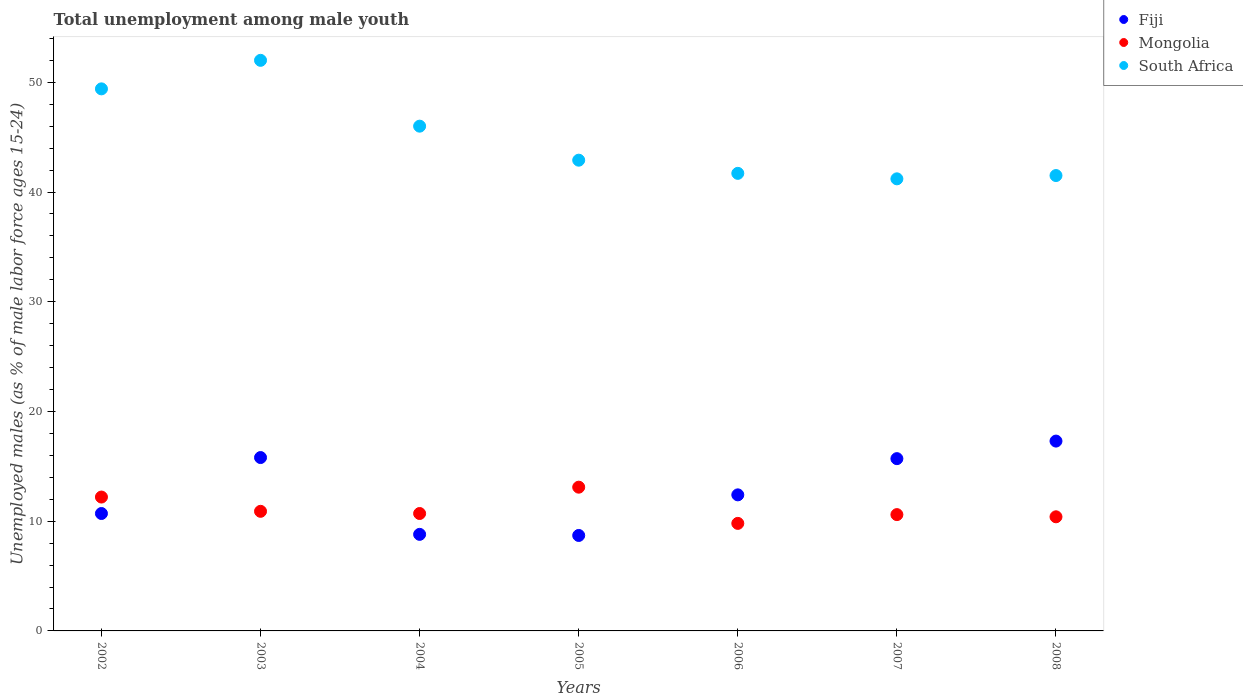What is the percentage of unemployed males in in Mongolia in 2004?
Give a very brief answer. 10.7. Across all years, what is the maximum percentage of unemployed males in in Mongolia?
Give a very brief answer. 13.1. Across all years, what is the minimum percentage of unemployed males in in South Africa?
Offer a terse response. 41.2. In which year was the percentage of unemployed males in in Mongolia minimum?
Your answer should be very brief. 2006. What is the total percentage of unemployed males in in South Africa in the graph?
Provide a short and direct response. 314.7. What is the difference between the percentage of unemployed males in in South Africa in 2002 and that in 2008?
Make the answer very short. 7.9. What is the difference between the percentage of unemployed males in in Fiji in 2002 and the percentage of unemployed males in in South Africa in 2003?
Offer a terse response. -41.3. What is the average percentage of unemployed males in in South Africa per year?
Your answer should be compact. 44.96. In the year 2005, what is the difference between the percentage of unemployed males in in Fiji and percentage of unemployed males in in Mongolia?
Your answer should be very brief. -4.4. What is the ratio of the percentage of unemployed males in in Mongolia in 2002 to that in 2004?
Make the answer very short. 1.14. Is the percentage of unemployed males in in South Africa in 2005 less than that in 2006?
Make the answer very short. No. What is the difference between the highest and the second highest percentage of unemployed males in in Mongolia?
Offer a terse response. 0.9. What is the difference between the highest and the lowest percentage of unemployed males in in Mongolia?
Make the answer very short. 3.3. Is the sum of the percentage of unemployed males in in Fiji in 2006 and 2008 greater than the maximum percentage of unemployed males in in Mongolia across all years?
Make the answer very short. Yes. Is it the case that in every year, the sum of the percentage of unemployed males in in Mongolia and percentage of unemployed males in in Fiji  is greater than the percentage of unemployed males in in South Africa?
Keep it short and to the point. No. Does the percentage of unemployed males in in South Africa monotonically increase over the years?
Offer a terse response. No. Is the percentage of unemployed males in in Fiji strictly greater than the percentage of unemployed males in in South Africa over the years?
Offer a very short reply. No. Is the percentage of unemployed males in in South Africa strictly less than the percentage of unemployed males in in Fiji over the years?
Your answer should be very brief. No. How many dotlines are there?
Offer a terse response. 3. How many years are there in the graph?
Give a very brief answer. 7. What is the difference between two consecutive major ticks on the Y-axis?
Make the answer very short. 10. Are the values on the major ticks of Y-axis written in scientific E-notation?
Provide a short and direct response. No. Where does the legend appear in the graph?
Ensure brevity in your answer.  Top right. How are the legend labels stacked?
Offer a terse response. Vertical. What is the title of the graph?
Your answer should be compact. Total unemployment among male youth. Does "Sudan" appear as one of the legend labels in the graph?
Give a very brief answer. No. What is the label or title of the Y-axis?
Provide a short and direct response. Unemployed males (as % of male labor force ages 15-24). What is the Unemployed males (as % of male labor force ages 15-24) of Fiji in 2002?
Your answer should be very brief. 10.7. What is the Unemployed males (as % of male labor force ages 15-24) of Mongolia in 2002?
Provide a succinct answer. 12.2. What is the Unemployed males (as % of male labor force ages 15-24) in South Africa in 2002?
Your response must be concise. 49.4. What is the Unemployed males (as % of male labor force ages 15-24) of Fiji in 2003?
Keep it short and to the point. 15.8. What is the Unemployed males (as % of male labor force ages 15-24) of Mongolia in 2003?
Your answer should be very brief. 10.9. What is the Unemployed males (as % of male labor force ages 15-24) of Fiji in 2004?
Give a very brief answer. 8.8. What is the Unemployed males (as % of male labor force ages 15-24) of Mongolia in 2004?
Your answer should be very brief. 10.7. What is the Unemployed males (as % of male labor force ages 15-24) in South Africa in 2004?
Provide a short and direct response. 46. What is the Unemployed males (as % of male labor force ages 15-24) of Fiji in 2005?
Make the answer very short. 8.7. What is the Unemployed males (as % of male labor force ages 15-24) in Mongolia in 2005?
Your response must be concise. 13.1. What is the Unemployed males (as % of male labor force ages 15-24) of South Africa in 2005?
Offer a very short reply. 42.9. What is the Unemployed males (as % of male labor force ages 15-24) in Fiji in 2006?
Your response must be concise. 12.4. What is the Unemployed males (as % of male labor force ages 15-24) in Mongolia in 2006?
Your answer should be very brief. 9.8. What is the Unemployed males (as % of male labor force ages 15-24) in South Africa in 2006?
Provide a short and direct response. 41.7. What is the Unemployed males (as % of male labor force ages 15-24) in Fiji in 2007?
Give a very brief answer. 15.7. What is the Unemployed males (as % of male labor force ages 15-24) of Mongolia in 2007?
Keep it short and to the point. 10.6. What is the Unemployed males (as % of male labor force ages 15-24) of South Africa in 2007?
Provide a succinct answer. 41.2. What is the Unemployed males (as % of male labor force ages 15-24) in Fiji in 2008?
Your answer should be compact. 17.3. What is the Unemployed males (as % of male labor force ages 15-24) of Mongolia in 2008?
Your response must be concise. 10.4. What is the Unemployed males (as % of male labor force ages 15-24) of South Africa in 2008?
Your response must be concise. 41.5. Across all years, what is the maximum Unemployed males (as % of male labor force ages 15-24) in Fiji?
Make the answer very short. 17.3. Across all years, what is the maximum Unemployed males (as % of male labor force ages 15-24) of Mongolia?
Your answer should be very brief. 13.1. Across all years, what is the minimum Unemployed males (as % of male labor force ages 15-24) of Fiji?
Offer a terse response. 8.7. Across all years, what is the minimum Unemployed males (as % of male labor force ages 15-24) in Mongolia?
Ensure brevity in your answer.  9.8. Across all years, what is the minimum Unemployed males (as % of male labor force ages 15-24) of South Africa?
Your answer should be compact. 41.2. What is the total Unemployed males (as % of male labor force ages 15-24) of Fiji in the graph?
Make the answer very short. 89.4. What is the total Unemployed males (as % of male labor force ages 15-24) of Mongolia in the graph?
Your response must be concise. 77.7. What is the total Unemployed males (as % of male labor force ages 15-24) in South Africa in the graph?
Your answer should be compact. 314.7. What is the difference between the Unemployed males (as % of male labor force ages 15-24) of Fiji in 2002 and that in 2003?
Your answer should be compact. -5.1. What is the difference between the Unemployed males (as % of male labor force ages 15-24) in Mongolia in 2002 and that in 2004?
Provide a short and direct response. 1.5. What is the difference between the Unemployed males (as % of male labor force ages 15-24) of South Africa in 2002 and that in 2004?
Provide a succinct answer. 3.4. What is the difference between the Unemployed males (as % of male labor force ages 15-24) of South Africa in 2002 and that in 2005?
Ensure brevity in your answer.  6.5. What is the difference between the Unemployed males (as % of male labor force ages 15-24) in Fiji in 2002 and that in 2006?
Your answer should be compact. -1.7. What is the difference between the Unemployed males (as % of male labor force ages 15-24) in Fiji in 2002 and that in 2007?
Provide a succinct answer. -5. What is the difference between the Unemployed males (as % of male labor force ages 15-24) in South Africa in 2002 and that in 2007?
Ensure brevity in your answer.  8.2. What is the difference between the Unemployed males (as % of male labor force ages 15-24) of Mongolia in 2002 and that in 2008?
Ensure brevity in your answer.  1.8. What is the difference between the Unemployed males (as % of male labor force ages 15-24) in South Africa in 2002 and that in 2008?
Offer a terse response. 7.9. What is the difference between the Unemployed males (as % of male labor force ages 15-24) in Fiji in 2003 and that in 2004?
Ensure brevity in your answer.  7. What is the difference between the Unemployed males (as % of male labor force ages 15-24) of Mongolia in 2003 and that in 2004?
Ensure brevity in your answer.  0.2. What is the difference between the Unemployed males (as % of male labor force ages 15-24) of South Africa in 2003 and that in 2004?
Make the answer very short. 6. What is the difference between the Unemployed males (as % of male labor force ages 15-24) of South Africa in 2003 and that in 2005?
Ensure brevity in your answer.  9.1. What is the difference between the Unemployed males (as % of male labor force ages 15-24) in Mongolia in 2003 and that in 2006?
Your answer should be compact. 1.1. What is the difference between the Unemployed males (as % of male labor force ages 15-24) in South Africa in 2003 and that in 2006?
Your response must be concise. 10.3. What is the difference between the Unemployed males (as % of male labor force ages 15-24) of Fiji in 2003 and that in 2007?
Your answer should be very brief. 0.1. What is the difference between the Unemployed males (as % of male labor force ages 15-24) in South Africa in 2003 and that in 2007?
Your answer should be compact. 10.8. What is the difference between the Unemployed males (as % of male labor force ages 15-24) of Fiji in 2003 and that in 2008?
Ensure brevity in your answer.  -1.5. What is the difference between the Unemployed males (as % of male labor force ages 15-24) in Mongolia in 2004 and that in 2005?
Provide a succinct answer. -2.4. What is the difference between the Unemployed males (as % of male labor force ages 15-24) in Mongolia in 2004 and that in 2006?
Your answer should be very brief. 0.9. What is the difference between the Unemployed males (as % of male labor force ages 15-24) of South Africa in 2004 and that in 2006?
Provide a succinct answer. 4.3. What is the difference between the Unemployed males (as % of male labor force ages 15-24) in South Africa in 2004 and that in 2008?
Offer a very short reply. 4.5. What is the difference between the Unemployed males (as % of male labor force ages 15-24) in Fiji in 2005 and that in 2006?
Offer a very short reply. -3.7. What is the difference between the Unemployed males (as % of male labor force ages 15-24) in Mongolia in 2005 and that in 2006?
Your response must be concise. 3.3. What is the difference between the Unemployed males (as % of male labor force ages 15-24) of South Africa in 2005 and that in 2006?
Provide a succinct answer. 1.2. What is the difference between the Unemployed males (as % of male labor force ages 15-24) of Mongolia in 2005 and that in 2008?
Make the answer very short. 2.7. What is the difference between the Unemployed males (as % of male labor force ages 15-24) in Fiji in 2006 and that in 2007?
Provide a short and direct response. -3.3. What is the difference between the Unemployed males (as % of male labor force ages 15-24) of Mongolia in 2006 and that in 2007?
Offer a very short reply. -0.8. What is the difference between the Unemployed males (as % of male labor force ages 15-24) of Mongolia in 2006 and that in 2008?
Give a very brief answer. -0.6. What is the difference between the Unemployed males (as % of male labor force ages 15-24) in Mongolia in 2007 and that in 2008?
Your answer should be very brief. 0.2. What is the difference between the Unemployed males (as % of male labor force ages 15-24) of Fiji in 2002 and the Unemployed males (as % of male labor force ages 15-24) of South Africa in 2003?
Your response must be concise. -41.3. What is the difference between the Unemployed males (as % of male labor force ages 15-24) of Mongolia in 2002 and the Unemployed males (as % of male labor force ages 15-24) of South Africa in 2003?
Keep it short and to the point. -39.8. What is the difference between the Unemployed males (as % of male labor force ages 15-24) of Fiji in 2002 and the Unemployed males (as % of male labor force ages 15-24) of Mongolia in 2004?
Your response must be concise. 0. What is the difference between the Unemployed males (as % of male labor force ages 15-24) in Fiji in 2002 and the Unemployed males (as % of male labor force ages 15-24) in South Africa in 2004?
Your answer should be compact. -35.3. What is the difference between the Unemployed males (as % of male labor force ages 15-24) of Mongolia in 2002 and the Unemployed males (as % of male labor force ages 15-24) of South Africa in 2004?
Your response must be concise. -33.8. What is the difference between the Unemployed males (as % of male labor force ages 15-24) in Fiji in 2002 and the Unemployed males (as % of male labor force ages 15-24) in South Africa in 2005?
Give a very brief answer. -32.2. What is the difference between the Unemployed males (as % of male labor force ages 15-24) of Mongolia in 2002 and the Unemployed males (as % of male labor force ages 15-24) of South Africa in 2005?
Give a very brief answer. -30.7. What is the difference between the Unemployed males (as % of male labor force ages 15-24) of Fiji in 2002 and the Unemployed males (as % of male labor force ages 15-24) of Mongolia in 2006?
Provide a succinct answer. 0.9. What is the difference between the Unemployed males (as % of male labor force ages 15-24) of Fiji in 2002 and the Unemployed males (as % of male labor force ages 15-24) of South Africa in 2006?
Keep it short and to the point. -31. What is the difference between the Unemployed males (as % of male labor force ages 15-24) of Mongolia in 2002 and the Unemployed males (as % of male labor force ages 15-24) of South Africa in 2006?
Your response must be concise. -29.5. What is the difference between the Unemployed males (as % of male labor force ages 15-24) of Fiji in 2002 and the Unemployed males (as % of male labor force ages 15-24) of South Africa in 2007?
Ensure brevity in your answer.  -30.5. What is the difference between the Unemployed males (as % of male labor force ages 15-24) of Mongolia in 2002 and the Unemployed males (as % of male labor force ages 15-24) of South Africa in 2007?
Ensure brevity in your answer.  -29. What is the difference between the Unemployed males (as % of male labor force ages 15-24) in Fiji in 2002 and the Unemployed males (as % of male labor force ages 15-24) in Mongolia in 2008?
Give a very brief answer. 0.3. What is the difference between the Unemployed males (as % of male labor force ages 15-24) in Fiji in 2002 and the Unemployed males (as % of male labor force ages 15-24) in South Africa in 2008?
Your response must be concise. -30.8. What is the difference between the Unemployed males (as % of male labor force ages 15-24) in Mongolia in 2002 and the Unemployed males (as % of male labor force ages 15-24) in South Africa in 2008?
Offer a terse response. -29.3. What is the difference between the Unemployed males (as % of male labor force ages 15-24) of Fiji in 2003 and the Unemployed males (as % of male labor force ages 15-24) of South Africa in 2004?
Give a very brief answer. -30.2. What is the difference between the Unemployed males (as % of male labor force ages 15-24) of Mongolia in 2003 and the Unemployed males (as % of male labor force ages 15-24) of South Africa in 2004?
Ensure brevity in your answer.  -35.1. What is the difference between the Unemployed males (as % of male labor force ages 15-24) of Fiji in 2003 and the Unemployed males (as % of male labor force ages 15-24) of Mongolia in 2005?
Offer a terse response. 2.7. What is the difference between the Unemployed males (as % of male labor force ages 15-24) in Fiji in 2003 and the Unemployed males (as % of male labor force ages 15-24) in South Africa in 2005?
Your answer should be compact. -27.1. What is the difference between the Unemployed males (as % of male labor force ages 15-24) in Mongolia in 2003 and the Unemployed males (as % of male labor force ages 15-24) in South Africa in 2005?
Offer a very short reply. -32. What is the difference between the Unemployed males (as % of male labor force ages 15-24) in Fiji in 2003 and the Unemployed males (as % of male labor force ages 15-24) in Mongolia in 2006?
Your response must be concise. 6. What is the difference between the Unemployed males (as % of male labor force ages 15-24) of Fiji in 2003 and the Unemployed males (as % of male labor force ages 15-24) of South Africa in 2006?
Your response must be concise. -25.9. What is the difference between the Unemployed males (as % of male labor force ages 15-24) in Mongolia in 2003 and the Unemployed males (as % of male labor force ages 15-24) in South Africa in 2006?
Your answer should be compact. -30.8. What is the difference between the Unemployed males (as % of male labor force ages 15-24) of Fiji in 2003 and the Unemployed males (as % of male labor force ages 15-24) of Mongolia in 2007?
Give a very brief answer. 5.2. What is the difference between the Unemployed males (as % of male labor force ages 15-24) of Fiji in 2003 and the Unemployed males (as % of male labor force ages 15-24) of South Africa in 2007?
Make the answer very short. -25.4. What is the difference between the Unemployed males (as % of male labor force ages 15-24) in Mongolia in 2003 and the Unemployed males (as % of male labor force ages 15-24) in South Africa in 2007?
Ensure brevity in your answer.  -30.3. What is the difference between the Unemployed males (as % of male labor force ages 15-24) of Fiji in 2003 and the Unemployed males (as % of male labor force ages 15-24) of South Africa in 2008?
Give a very brief answer. -25.7. What is the difference between the Unemployed males (as % of male labor force ages 15-24) of Mongolia in 2003 and the Unemployed males (as % of male labor force ages 15-24) of South Africa in 2008?
Your answer should be compact. -30.6. What is the difference between the Unemployed males (as % of male labor force ages 15-24) in Fiji in 2004 and the Unemployed males (as % of male labor force ages 15-24) in Mongolia in 2005?
Keep it short and to the point. -4.3. What is the difference between the Unemployed males (as % of male labor force ages 15-24) of Fiji in 2004 and the Unemployed males (as % of male labor force ages 15-24) of South Africa in 2005?
Offer a very short reply. -34.1. What is the difference between the Unemployed males (as % of male labor force ages 15-24) of Mongolia in 2004 and the Unemployed males (as % of male labor force ages 15-24) of South Africa in 2005?
Your answer should be compact. -32.2. What is the difference between the Unemployed males (as % of male labor force ages 15-24) in Fiji in 2004 and the Unemployed males (as % of male labor force ages 15-24) in Mongolia in 2006?
Ensure brevity in your answer.  -1. What is the difference between the Unemployed males (as % of male labor force ages 15-24) of Fiji in 2004 and the Unemployed males (as % of male labor force ages 15-24) of South Africa in 2006?
Provide a succinct answer. -32.9. What is the difference between the Unemployed males (as % of male labor force ages 15-24) in Mongolia in 2004 and the Unemployed males (as % of male labor force ages 15-24) in South Africa in 2006?
Provide a short and direct response. -31. What is the difference between the Unemployed males (as % of male labor force ages 15-24) in Fiji in 2004 and the Unemployed males (as % of male labor force ages 15-24) in South Africa in 2007?
Offer a terse response. -32.4. What is the difference between the Unemployed males (as % of male labor force ages 15-24) in Mongolia in 2004 and the Unemployed males (as % of male labor force ages 15-24) in South Africa in 2007?
Give a very brief answer. -30.5. What is the difference between the Unemployed males (as % of male labor force ages 15-24) of Fiji in 2004 and the Unemployed males (as % of male labor force ages 15-24) of Mongolia in 2008?
Your response must be concise. -1.6. What is the difference between the Unemployed males (as % of male labor force ages 15-24) of Fiji in 2004 and the Unemployed males (as % of male labor force ages 15-24) of South Africa in 2008?
Your response must be concise. -32.7. What is the difference between the Unemployed males (as % of male labor force ages 15-24) of Mongolia in 2004 and the Unemployed males (as % of male labor force ages 15-24) of South Africa in 2008?
Provide a short and direct response. -30.8. What is the difference between the Unemployed males (as % of male labor force ages 15-24) in Fiji in 2005 and the Unemployed males (as % of male labor force ages 15-24) in Mongolia in 2006?
Provide a short and direct response. -1.1. What is the difference between the Unemployed males (as % of male labor force ages 15-24) of Fiji in 2005 and the Unemployed males (as % of male labor force ages 15-24) of South Africa in 2006?
Offer a very short reply. -33. What is the difference between the Unemployed males (as % of male labor force ages 15-24) in Mongolia in 2005 and the Unemployed males (as % of male labor force ages 15-24) in South Africa in 2006?
Your answer should be very brief. -28.6. What is the difference between the Unemployed males (as % of male labor force ages 15-24) in Fiji in 2005 and the Unemployed males (as % of male labor force ages 15-24) in South Africa in 2007?
Provide a short and direct response. -32.5. What is the difference between the Unemployed males (as % of male labor force ages 15-24) in Mongolia in 2005 and the Unemployed males (as % of male labor force ages 15-24) in South Africa in 2007?
Your response must be concise. -28.1. What is the difference between the Unemployed males (as % of male labor force ages 15-24) in Fiji in 2005 and the Unemployed males (as % of male labor force ages 15-24) in Mongolia in 2008?
Provide a succinct answer. -1.7. What is the difference between the Unemployed males (as % of male labor force ages 15-24) of Fiji in 2005 and the Unemployed males (as % of male labor force ages 15-24) of South Africa in 2008?
Your response must be concise. -32.8. What is the difference between the Unemployed males (as % of male labor force ages 15-24) of Mongolia in 2005 and the Unemployed males (as % of male labor force ages 15-24) of South Africa in 2008?
Your response must be concise. -28.4. What is the difference between the Unemployed males (as % of male labor force ages 15-24) in Fiji in 2006 and the Unemployed males (as % of male labor force ages 15-24) in South Africa in 2007?
Offer a very short reply. -28.8. What is the difference between the Unemployed males (as % of male labor force ages 15-24) in Mongolia in 2006 and the Unemployed males (as % of male labor force ages 15-24) in South Africa in 2007?
Your response must be concise. -31.4. What is the difference between the Unemployed males (as % of male labor force ages 15-24) in Fiji in 2006 and the Unemployed males (as % of male labor force ages 15-24) in South Africa in 2008?
Ensure brevity in your answer.  -29.1. What is the difference between the Unemployed males (as % of male labor force ages 15-24) in Mongolia in 2006 and the Unemployed males (as % of male labor force ages 15-24) in South Africa in 2008?
Your answer should be compact. -31.7. What is the difference between the Unemployed males (as % of male labor force ages 15-24) of Fiji in 2007 and the Unemployed males (as % of male labor force ages 15-24) of Mongolia in 2008?
Offer a very short reply. 5.3. What is the difference between the Unemployed males (as % of male labor force ages 15-24) of Fiji in 2007 and the Unemployed males (as % of male labor force ages 15-24) of South Africa in 2008?
Ensure brevity in your answer.  -25.8. What is the difference between the Unemployed males (as % of male labor force ages 15-24) in Mongolia in 2007 and the Unemployed males (as % of male labor force ages 15-24) in South Africa in 2008?
Your answer should be compact. -30.9. What is the average Unemployed males (as % of male labor force ages 15-24) of Fiji per year?
Your response must be concise. 12.77. What is the average Unemployed males (as % of male labor force ages 15-24) in Mongolia per year?
Provide a short and direct response. 11.1. What is the average Unemployed males (as % of male labor force ages 15-24) in South Africa per year?
Give a very brief answer. 44.96. In the year 2002, what is the difference between the Unemployed males (as % of male labor force ages 15-24) in Fiji and Unemployed males (as % of male labor force ages 15-24) in Mongolia?
Offer a terse response. -1.5. In the year 2002, what is the difference between the Unemployed males (as % of male labor force ages 15-24) in Fiji and Unemployed males (as % of male labor force ages 15-24) in South Africa?
Make the answer very short. -38.7. In the year 2002, what is the difference between the Unemployed males (as % of male labor force ages 15-24) of Mongolia and Unemployed males (as % of male labor force ages 15-24) of South Africa?
Your response must be concise. -37.2. In the year 2003, what is the difference between the Unemployed males (as % of male labor force ages 15-24) of Fiji and Unemployed males (as % of male labor force ages 15-24) of South Africa?
Your answer should be compact. -36.2. In the year 2003, what is the difference between the Unemployed males (as % of male labor force ages 15-24) in Mongolia and Unemployed males (as % of male labor force ages 15-24) in South Africa?
Your answer should be compact. -41.1. In the year 2004, what is the difference between the Unemployed males (as % of male labor force ages 15-24) of Fiji and Unemployed males (as % of male labor force ages 15-24) of South Africa?
Make the answer very short. -37.2. In the year 2004, what is the difference between the Unemployed males (as % of male labor force ages 15-24) in Mongolia and Unemployed males (as % of male labor force ages 15-24) in South Africa?
Provide a succinct answer. -35.3. In the year 2005, what is the difference between the Unemployed males (as % of male labor force ages 15-24) in Fiji and Unemployed males (as % of male labor force ages 15-24) in Mongolia?
Offer a terse response. -4.4. In the year 2005, what is the difference between the Unemployed males (as % of male labor force ages 15-24) of Fiji and Unemployed males (as % of male labor force ages 15-24) of South Africa?
Provide a short and direct response. -34.2. In the year 2005, what is the difference between the Unemployed males (as % of male labor force ages 15-24) in Mongolia and Unemployed males (as % of male labor force ages 15-24) in South Africa?
Your response must be concise. -29.8. In the year 2006, what is the difference between the Unemployed males (as % of male labor force ages 15-24) of Fiji and Unemployed males (as % of male labor force ages 15-24) of Mongolia?
Offer a very short reply. 2.6. In the year 2006, what is the difference between the Unemployed males (as % of male labor force ages 15-24) in Fiji and Unemployed males (as % of male labor force ages 15-24) in South Africa?
Ensure brevity in your answer.  -29.3. In the year 2006, what is the difference between the Unemployed males (as % of male labor force ages 15-24) in Mongolia and Unemployed males (as % of male labor force ages 15-24) in South Africa?
Your response must be concise. -31.9. In the year 2007, what is the difference between the Unemployed males (as % of male labor force ages 15-24) in Fiji and Unemployed males (as % of male labor force ages 15-24) in South Africa?
Keep it short and to the point. -25.5. In the year 2007, what is the difference between the Unemployed males (as % of male labor force ages 15-24) in Mongolia and Unemployed males (as % of male labor force ages 15-24) in South Africa?
Keep it short and to the point. -30.6. In the year 2008, what is the difference between the Unemployed males (as % of male labor force ages 15-24) of Fiji and Unemployed males (as % of male labor force ages 15-24) of Mongolia?
Your answer should be very brief. 6.9. In the year 2008, what is the difference between the Unemployed males (as % of male labor force ages 15-24) of Fiji and Unemployed males (as % of male labor force ages 15-24) of South Africa?
Make the answer very short. -24.2. In the year 2008, what is the difference between the Unemployed males (as % of male labor force ages 15-24) of Mongolia and Unemployed males (as % of male labor force ages 15-24) of South Africa?
Ensure brevity in your answer.  -31.1. What is the ratio of the Unemployed males (as % of male labor force ages 15-24) in Fiji in 2002 to that in 2003?
Your response must be concise. 0.68. What is the ratio of the Unemployed males (as % of male labor force ages 15-24) of Mongolia in 2002 to that in 2003?
Your answer should be very brief. 1.12. What is the ratio of the Unemployed males (as % of male labor force ages 15-24) in South Africa in 2002 to that in 2003?
Provide a succinct answer. 0.95. What is the ratio of the Unemployed males (as % of male labor force ages 15-24) of Fiji in 2002 to that in 2004?
Make the answer very short. 1.22. What is the ratio of the Unemployed males (as % of male labor force ages 15-24) of Mongolia in 2002 to that in 2004?
Provide a short and direct response. 1.14. What is the ratio of the Unemployed males (as % of male labor force ages 15-24) in South Africa in 2002 to that in 2004?
Provide a short and direct response. 1.07. What is the ratio of the Unemployed males (as % of male labor force ages 15-24) of Fiji in 2002 to that in 2005?
Offer a terse response. 1.23. What is the ratio of the Unemployed males (as % of male labor force ages 15-24) of Mongolia in 2002 to that in 2005?
Give a very brief answer. 0.93. What is the ratio of the Unemployed males (as % of male labor force ages 15-24) of South Africa in 2002 to that in 2005?
Your response must be concise. 1.15. What is the ratio of the Unemployed males (as % of male labor force ages 15-24) in Fiji in 2002 to that in 2006?
Ensure brevity in your answer.  0.86. What is the ratio of the Unemployed males (as % of male labor force ages 15-24) in Mongolia in 2002 to that in 2006?
Your response must be concise. 1.24. What is the ratio of the Unemployed males (as % of male labor force ages 15-24) in South Africa in 2002 to that in 2006?
Your answer should be compact. 1.18. What is the ratio of the Unemployed males (as % of male labor force ages 15-24) of Fiji in 2002 to that in 2007?
Provide a succinct answer. 0.68. What is the ratio of the Unemployed males (as % of male labor force ages 15-24) of Mongolia in 2002 to that in 2007?
Give a very brief answer. 1.15. What is the ratio of the Unemployed males (as % of male labor force ages 15-24) of South Africa in 2002 to that in 2007?
Ensure brevity in your answer.  1.2. What is the ratio of the Unemployed males (as % of male labor force ages 15-24) of Fiji in 2002 to that in 2008?
Give a very brief answer. 0.62. What is the ratio of the Unemployed males (as % of male labor force ages 15-24) in Mongolia in 2002 to that in 2008?
Keep it short and to the point. 1.17. What is the ratio of the Unemployed males (as % of male labor force ages 15-24) of South Africa in 2002 to that in 2008?
Make the answer very short. 1.19. What is the ratio of the Unemployed males (as % of male labor force ages 15-24) in Fiji in 2003 to that in 2004?
Your answer should be compact. 1.8. What is the ratio of the Unemployed males (as % of male labor force ages 15-24) of Mongolia in 2003 to that in 2004?
Your response must be concise. 1.02. What is the ratio of the Unemployed males (as % of male labor force ages 15-24) of South Africa in 2003 to that in 2004?
Your response must be concise. 1.13. What is the ratio of the Unemployed males (as % of male labor force ages 15-24) of Fiji in 2003 to that in 2005?
Keep it short and to the point. 1.82. What is the ratio of the Unemployed males (as % of male labor force ages 15-24) in Mongolia in 2003 to that in 2005?
Ensure brevity in your answer.  0.83. What is the ratio of the Unemployed males (as % of male labor force ages 15-24) of South Africa in 2003 to that in 2005?
Offer a very short reply. 1.21. What is the ratio of the Unemployed males (as % of male labor force ages 15-24) in Fiji in 2003 to that in 2006?
Your response must be concise. 1.27. What is the ratio of the Unemployed males (as % of male labor force ages 15-24) of Mongolia in 2003 to that in 2006?
Keep it short and to the point. 1.11. What is the ratio of the Unemployed males (as % of male labor force ages 15-24) in South Africa in 2003 to that in 2006?
Your response must be concise. 1.25. What is the ratio of the Unemployed males (as % of male labor force ages 15-24) in Fiji in 2003 to that in 2007?
Keep it short and to the point. 1.01. What is the ratio of the Unemployed males (as % of male labor force ages 15-24) in Mongolia in 2003 to that in 2007?
Make the answer very short. 1.03. What is the ratio of the Unemployed males (as % of male labor force ages 15-24) in South Africa in 2003 to that in 2007?
Your answer should be compact. 1.26. What is the ratio of the Unemployed males (as % of male labor force ages 15-24) in Fiji in 2003 to that in 2008?
Offer a very short reply. 0.91. What is the ratio of the Unemployed males (as % of male labor force ages 15-24) in Mongolia in 2003 to that in 2008?
Give a very brief answer. 1.05. What is the ratio of the Unemployed males (as % of male labor force ages 15-24) in South Africa in 2003 to that in 2008?
Your answer should be very brief. 1.25. What is the ratio of the Unemployed males (as % of male labor force ages 15-24) of Fiji in 2004 to that in 2005?
Keep it short and to the point. 1.01. What is the ratio of the Unemployed males (as % of male labor force ages 15-24) of Mongolia in 2004 to that in 2005?
Your answer should be compact. 0.82. What is the ratio of the Unemployed males (as % of male labor force ages 15-24) of South Africa in 2004 to that in 2005?
Provide a succinct answer. 1.07. What is the ratio of the Unemployed males (as % of male labor force ages 15-24) of Fiji in 2004 to that in 2006?
Your answer should be compact. 0.71. What is the ratio of the Unemployed males (as % of male labor force ages 15-24) in Mongolia in 2004 to that in 2006?
Make the answer very short. 1.09. What is the ratio of the Unemployed males (as % of male labor force ages 15-24) of South Africa in 2004 to that in 2006?
Offer a very short reply. 1.1. What is the ratio of the Unemployed males (as % of male labor force ages 15-24) in Fiji in 2004 to that in 2007?
Keep it short and to the point. 0.56. What is the ratio of the Unemployed males (as % of male labor force ages 15-24) in Mongolia in 2004 to that in 2007?
Your answer should be very brief. 1.01. What is the ratio of the Unemployed males (as % of male labor force ages 15-24) in South Africa in 2004 to that in 2007?
Your answer should be compact. 1.12. What is the ratio of the Unemployed males (as % of male labor force ages 15-24) of Fiji in 2004 to that in 2008?
Give a very brief answer. 0.51. What is the ratio of the Unemployed males (as % of male labor force ages 15-24) in Mongolia in 2004 to that in 2008?
Give a very brief answer. 1.03. What is the ratio of the Unemployed males (as % of male labor force ages 15-24) in South Africa in 2004 to that in 2008?
Offer a very short reply. 1.11. What is the ratio of the Unemployed males (as % of male labor force ages 15-24) of Fiji in 2005 to that in 2006?
Keep it short and to the point. 0.7. What is the ratio of the Unemployed males (as % of male labor force ages 15-24) of Mongolia in 2005 to that in 2006?
Offer a terse response. 1.34. What is the ratio of the Unemployed males (as % of male labor force ages 15-24) in South Africa in 2005 to that in 2006?
Ensure brevity in your answer.  1.03. What is the ratio of the Unemployed males (as % of male labor force ages 15-24) of Fiji in 2005 to that in 2007?
Offer a very short reply. 0.55. What is the ratio of the Unemployed males (as % of male labor force ages 15-24) of Mongolia in 2005 to that in 2007?
Your answer should be compact. 1.24. What is the ratio of the Unemployed males (as % of male labor force ages 15-24) of South Africa in 2005 to that in 2007?
Offer a very short reply. 1.04. What is the ratio of the Unemployed males (as % of male labor force ages 15-24) of Fiji in 2005 to that in 2008?
Offer a terse response. 0.5. What is the ratio of the Unemployed males (as % of male labor force ages 15-24) in Mongolia in 2005 to that in 2008?
Make the answer very short. 1.26. What is the ratio of the Unemployed males (as % of male labor force ages 15-24) in South Africa in 2005 to that in 2008?
Your answer should be compact. 1.03. What is the ratio of the Unemployed males (as % of male labor force ages 15-24) in Fiji in 2006 to that in 2007?
Your answer should be compact. 0.79. What is the ratio of the Unemployed males (as % of male labor force ages 15-24) of Mongolia in 2006 to that in 2007?
Your response must be concise. 0.92. What is the ratio of the Unemployed males (as % of male labor force ages 15-24) in South Africa in 2006 to that in 2007?
Make the answer very short. 1.01. What is the ratio of the Unemployed males (as % of male labor force ages 15-24) in Fiji in 2006 to that in 2008?
Offer a terse response. 0.72. What is the ratio of the Unemployed males (as % of male labor force ages 15-24) in Mongolia in 2006 to that in 2008?
Provide a short and direct response. 0.94. What is the ratio of the Unemployed males (as % of male labor force ages 15-24) in Fiji in 2007 to that in 2008?
Ensure brevity in your answer.  0.91. What is the ratio of the Unemployed males (as % of male labor force ages 15-24) of Mongolia in 2007 to that in 2008?
Your answer should be compact. 1.02. What is the difference between the highest and the second highest Unemployed males (as % of male labor force ages 15-24) of South Africa?
Your answer should be very brief. 2.6. 